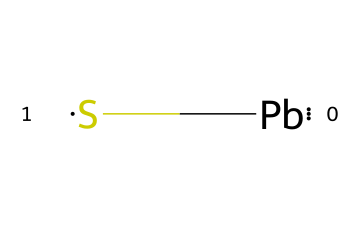What elements are present in lead sulfide quantum dots? The chemical structure contains two elements: lead (Pb) and sulfur (S), which are explicitly represented in the SMILES notation.
Answer: lead, sulfur How many atoms are in the chemical structure of lead sulfide? The SMILES notation indicates one atom of lead and one atom of sulfur, totaling two atoms.
Answer: two What is the molecular formula of lead sulfide quantum dots? The structure consists of one lead atom and one sulfur atom, which gives the molecular formula of PbS.
Answer: PbS What type of bond is present between the lead and sulfur atoms in quantum dots? The bond between lead and sulfur is a covalent bond, as evidenced by their close association in the molecular structure.
Answer: covalent Why are lead sulfide quantum dots suitable for near-infrared applications? Lead sulfide is known for its small bandgap, allowing it to effectively absorb and convert near-infrared light, making it ideal for responsive applications.
Answer: small bandgap What property of lead makes it useful in quantum dots for murals? Lead provides unique electronic properties that enhance the quantum dot's efficiency in photonic applications, particularly in the near-infrared spectrum.
Answer: electronic properties How does the presence of sulfur affect the stability of lead sulfide quantum dots? Sulfur contributes to the stability of the quantum dots by forming a stable covalent bond with lead, which helps maintain the desired structural integrity.
Answer: stability 